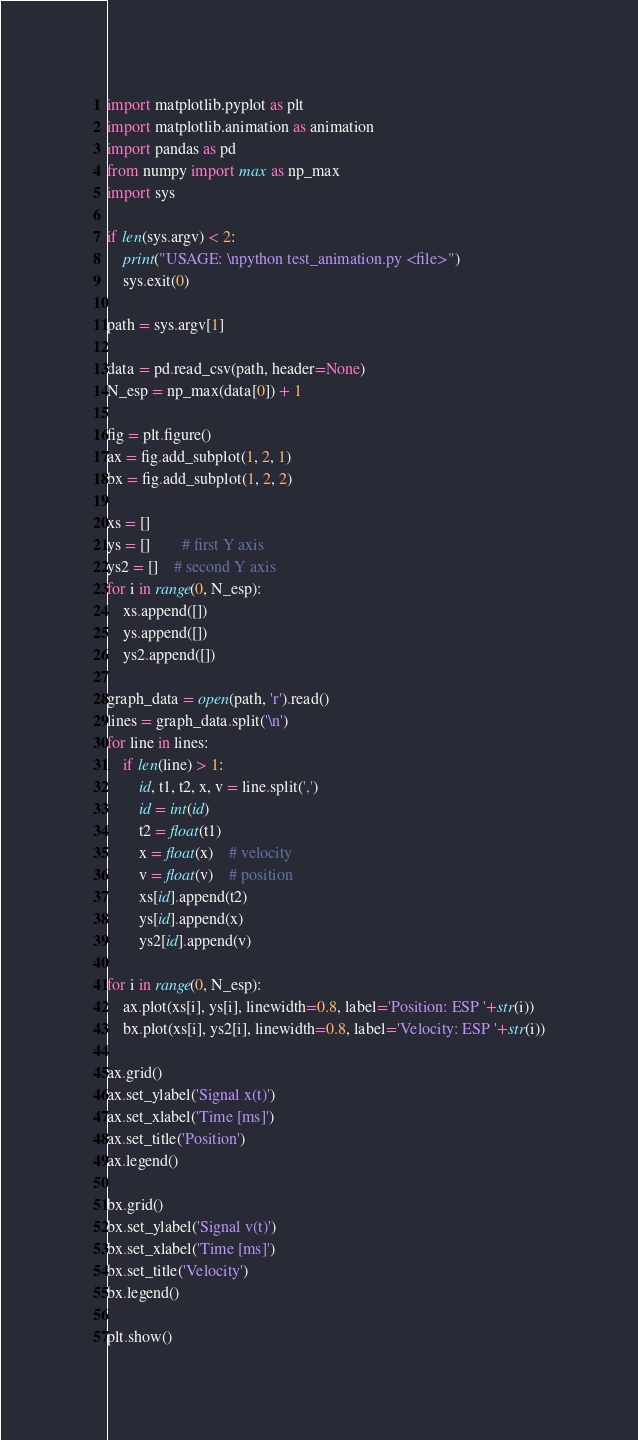Convert code to text. <code><loc_0><loc_0><loc_500><loc_500><_Python_>import matplotlib.pyplot as plt
import matplotlib.animation as animation
import pandas as pd
from numpy import max as np_max
import sys

if len(sys.argv) < 2:
	print("USAGE: \npython test_animation.py <file>")
	sys.exit(0)

path = sys.argv[1]

data = pd.read_csv(path, header=None)
N_esp = np_max(data[0]) + 1

fig = plt.figure()
ax = fig.add_subplot(1, 2, 1)
bx = fig.add_subplot(1, 2, 2)

xs = []
ys = []		# first Y axis
ys2 = []	# second Y axis
for i in range(0, N_esp):
	xs.append([])
	ys.append([])
	ys2.append([])

graph_data = open(path, 'r').read()
lines = graph_data.split('\n')
for line in lines:
	if len(line) > 1:
		id, t1, t2, x, v = line.split(',')
		id = int(id)
		t2 = float(t1)
		x = float(x)	# velocity
		v = float(v)	# position
		xs[id].append(t2)
		ys[id].append(x)
		ys2[id].append(v)

for i in range(0, N_esp):
	ax.plot(xs[i], ys[i], linewidth=0.8, label='Position: ESP '+str(i))
	bx.plot(xs[i], ys2[i], linewidth=0.8, label='Velocity: ESP '+str(i))

ax.grid()
ax.set_ylabel('Signal x(t)')
ax.set_xlabel('Time [ms]')
ax.set_title('Position')
ax.legend()

bx.grid()
bx.set_ylabel('Signal v(t)')
bx.set_xlabel('Time [ms]')
bx.set_title('Velocity')
bx.legend()

plt.show()
</code> 